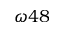Convert formula to latex. <formula><loc_0><loc_0><loc_500><loc_500>\omega 4 8</formula> 